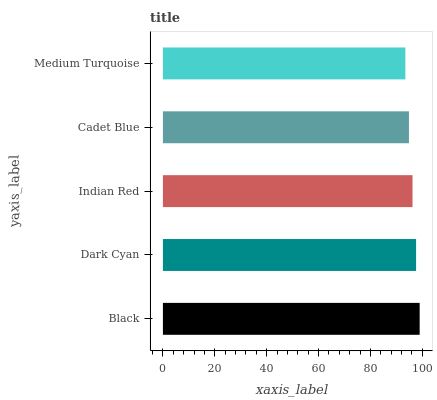Is Medium Turquoise the minimum?
Answer yes or no. Yes. Is Black the maximum?
Answer yes or no. Yes. Is Dark Cyan the minimum?
Answer yes or no. No. Is Dark Cyan the maximum?
Answer yes or no. No. Is Black greater than Dark Cyan?
Answer yes or no. Yes. Is Dark Cyan less than Black?
Answer yes or no. Yes. Is Dark Cyan greater than Black?
Answer yes or no. No. Is Black less than Dark Cyan?
Answer yes or no. No. Is Indian Red the high median?
Answer yes or no. Yes. Is Indian Red the low median?
Answer yes or no. Yes. Is Cadet Blue the high median?
Answer yes or no. No. Is Medium Turquoise the low median?
Answer yes or no. No. 